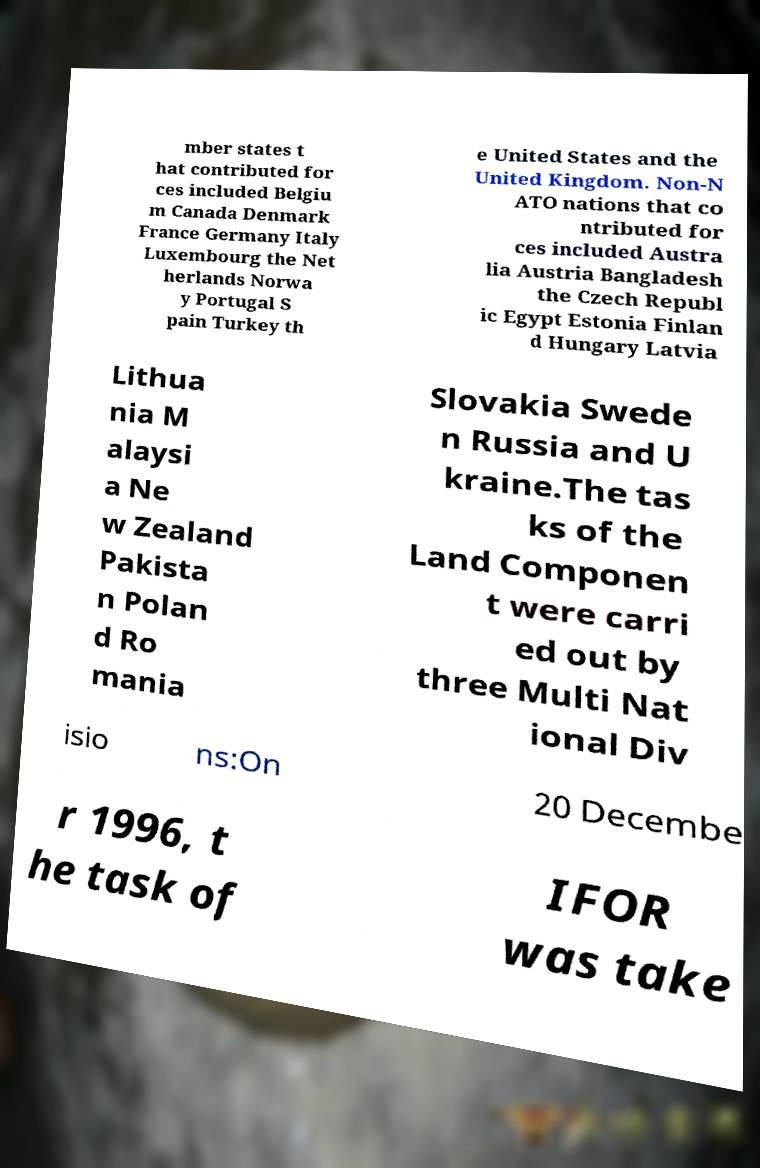For documentation purposes, I need the text within this image transcribed. Could you provide that? mber states t hat contributed for ces included Belgiu m Canada Denmark France Germany Italy Luxembourg the Net herlands Norwa y Portugal S pain Turkey th e United States and the United Kingdom. Non-N ATO nations that co ntributed for ces included Austra lia Austria Bangladesh the Czech Republ ic Egypt Estonia Finlan d Hungary Latvia Lithua nia M alaysi a Ne w Zealand Pakista n Polan d Ro mania Slovakia Swede n Russia and U kraine.The tas ks of the Land Componen t were carri ed out by three Multi Nat ional Div isio ns:On 20 Decembe r 1996, t he task of IFOR was take 